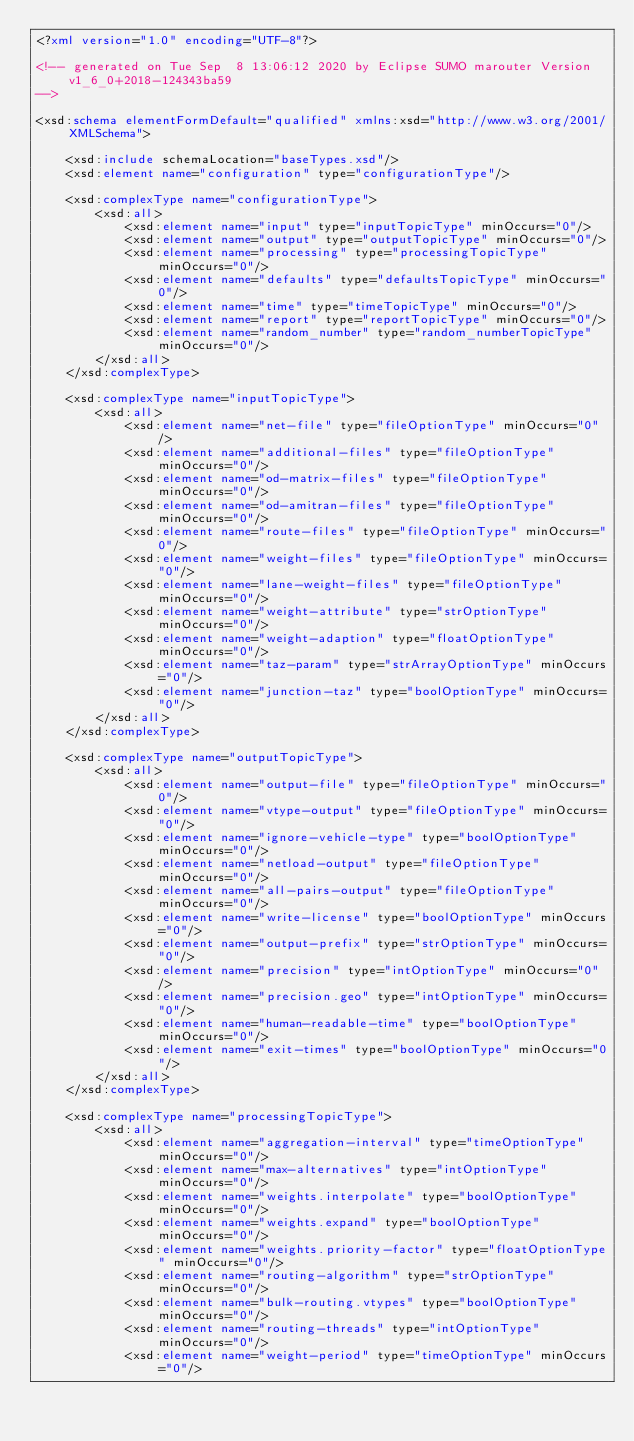<code> <loc_0><loc_0><loc_500><loc_500><_XML_><?xml version="1.0" encoding="UTF-8"?>

<!-- generated on Tue Sep  8 13:06:12 2020 by Eclipse SUMO marouter Version v1_6_0+2018-124343ba59
-->

<xsd:schema elementFormDefault="qualified" xmlns:xsd="http://www.w3.org/2001/XMLSchema">

    <xsd:include schemaLocation="baseTypes.xsd"/>
    <xsd:element name="configuration" type="configurationType"/>

    <xsd:complexType name="configurationType">
        <xsd:all>
            <xsd:element name="input" type="inputTopicType" minOccurs="0"/>
            <xsd:element name="output" type="outputTopicType" minOccurs="0"/>
            <xsd:element name="processing" type="processingTopicType" minOccurs="0"/>
            <xsd:element name="defaults" type="defaultsTopicType" minOccurs="0"/>
            <xsd:element name="time" type="timeTopicType" minOccurs="0"/>
            <xsd:element name="report" type="reportTopicType" minOccurs="0"/>
            <xsd:element name="random_number" type="random_numberTopicType" minOccurs="0"/>
        </xsd:all>
    </xsd:complexType>

    <xsd:complexType name="inputTopicType">
        <xsd:all>
            <xsd:element name="net-file" type="fileOptionType" minOccurs="0"/>
            <xsd:element name="additional-files" type="fileOptionType" minOccurs="0"/>
            <xsd:element name="od-matrix-files" type="fileOptionType" minOccurs="0"/>
            <xsd:element name="od-amitran-files" type="fileOptionType" minOccurs="0"/>
            <xsd:element name="route-files" type="fileOptionType" minOccurs="0"/>
            <xsd:element name="weight-files" type="fileOptionType" minOccurs="0"/>
            <xsd:element name="lane-weight-files" type="fileOptionType" minOccurs="0"/>
            <xsd:element name="weight-attribute" type="strOptionType" minOccurs="0"/>
            <xsd:element name="weight-adaption" type="floatOptionType" minOccurs="0"/>
            <xsd:element name="taz-param" type="strArrayOptionType" minOccurs="0"/>
            <xsd:element name="junction-taz" type="boolOptionType" minOccurs="0"/>
        </xsd:all>
    </xsd:complexType>

    <xsd:complexType name="outputTopicType">
        <xsd:all>
            <xsd:element name="output-file" type="fileOptionType" minOccurs="0"/>
            <xsd:element name="vtype-output" type="fileOptionType" minOccurs="0"/>
            <xsd:element name="ignore-vehicle-type" type="boolOptionType" minOccurs="0"/>
            <xsd:element name="netload-output" type="fileOptionType" minOccurs="0"/>
            <xsd:element name="all-pairs-output" type="fileOptionType" minOccurs="0"/>
            <xsd:element name="write-license" type="boolOptionType" minOccurs="0"/>
            <xsd:element name="output-prefix" type="strOptionType" minOccurs="0"/>
            <xsd:element name="precision" type="intOptionType" minOccurs="0"/>
            <xsd:element name="precision.geo" type="intOptionType" minOccurs="0"/>
            <xsd:element name="human-readable-time" type="boolOptionType" minOccurs="0"/>
            <xsd:element name="exit-times" type="boolOptionType" minOccurs="0"/>
        </xsd:all>
    </xsd:complexType>

    <xsd:complexType name="processingTopicType">
        <xsd:all>
            <xsd:element name="aggregation-interval" type="timeOptionType" minOccurs="0"/>
            <xsd:element name="max-alternatives" type="intOptionType" minOccurs="0"/>
            <xsd:element name="weights.interpolate" type="boolOptionType" minOccurs="0"/>
            <xsd:element name="weights.expand" type="boolOptionType" minOccurs="0"/>
            <xsd:element name="weights.priority-factor" type="floatOptionType" minOccurs="0"/>
            <xsd:element name="routing-algorithm" type="strOptionType" minOccurs="0"/>
            <xsd:element name="bulk-routing.vtypes" type="boolOptionType" minOccurs="0"/>
            <xsd:element name="routing-threads" type="intOptionType" minOccurs="0"/>
            <xsd:element name="weight-period" type="timeOptionType" minOccurs="0"/></code> 